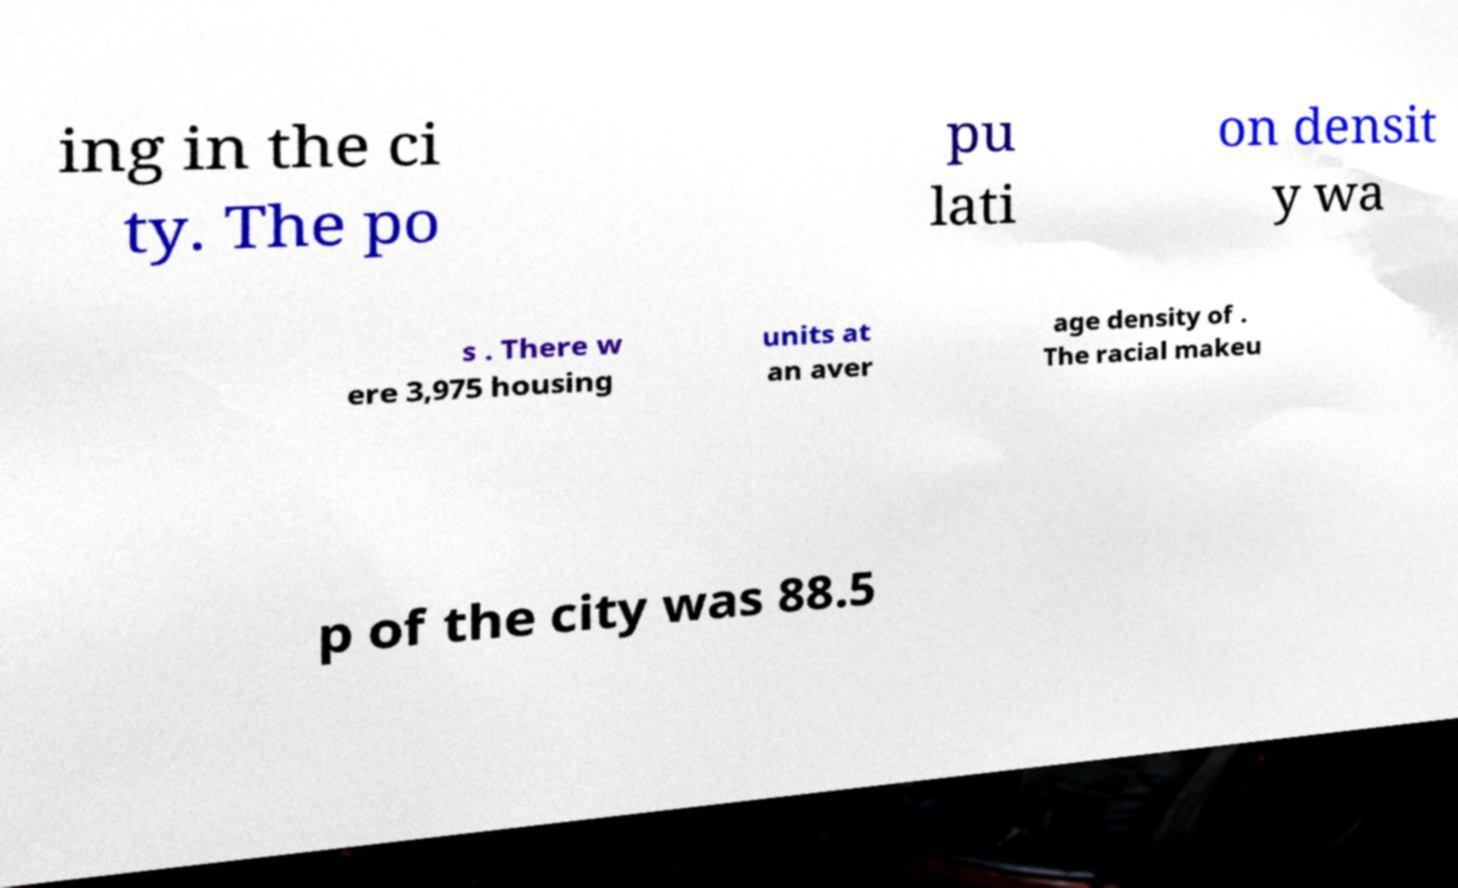There's text embedded in this image that I need extracted. Can you transcribe it verbatim? ing in the ci ty. The po pu lati on densit y wa s . There w ere 3,975 housing units at an aver age density of . The racial makeu p of the city was 88.5 